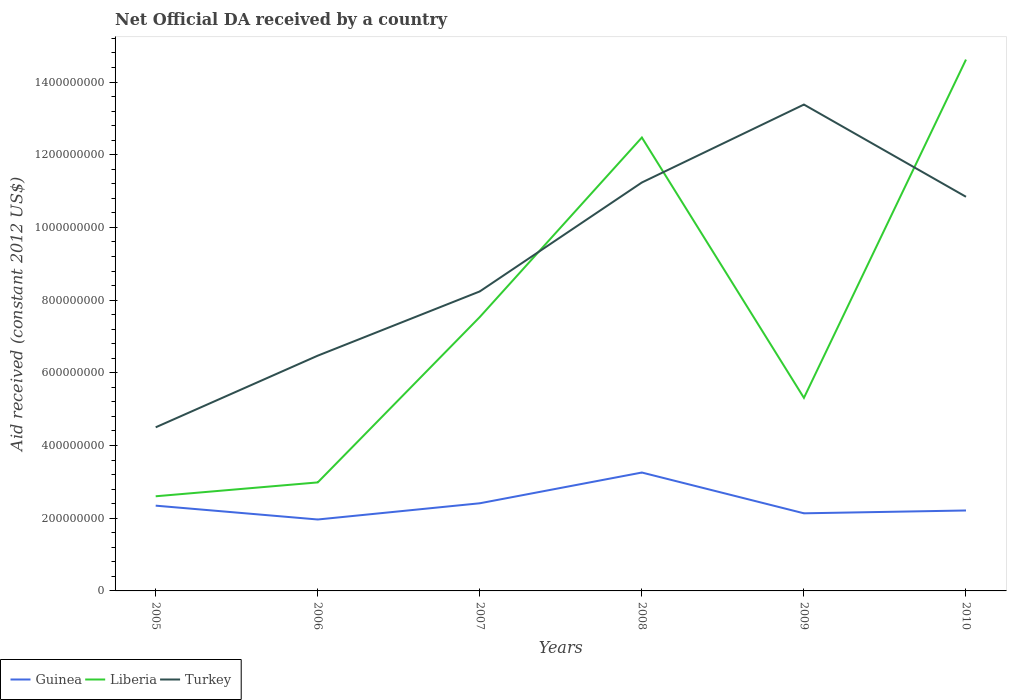How many different coloured lines are there?
Offer a terse response. 3. Does the line corresponding to Liberia intersect with the line corresponding to Turkey?
Give a very brief answer. Yes. Across all years, what is the maximum net official development assistance aid received in Liberia?
Keep it short and to the point. 2.60e+08. What is the total net official development assistance aid received in Liberia in the graph?
Your answer should be very brief. -1.16e+09. What is the difference between the highest and the second highest net official development assistance aid received in Liberia?
Offer a very short reply. 1.20e+09. What is the difference between the highest and the lowest net official development assistance aid received in Guinea?
Offer a terse response. 2. Is the net official development assistance aid received in Liberia strictly greater than the net official development assistance aid received in Turkey over the years?
Offer a terse response. No. How many years are there in the graph?
Keep it short and to the point. 6. What is the difference between two consecutive major ticks on the Y-axis?
Your answer should be compact. 2.00e+08. Where does the legend appear in the graph?
Provide a short and direct response. Bottom left. How are the legend labels stacked?
Your response must be concise. Horizontal. What is the title of the graph?
Give a very brief answer. Net Official DA received by a country. Does "Bahamas" appear as one of the legend labels in the graph?
Provide a succinct answer. No. What is the label or title of the Y-axis?
Keep it short and to the point. Aid received (constant 2012 US$). What is the Aid received (constant 2012 US$) in Guinea in 2005?
Offer a very short reply. 2.35e+08. What is the Aid received (constant 2012 US$) of Liberia in 2005?
Your answer should be compact. 2.60e+08. What is the Aid received (constant 2012 US$) in Turkey in 2005?
Offer a very short reply. 4.50e+08. What is the Aid received (constant 2012 US$) in Guinea in 2006?
Your response must be concise. 1.96e+08. What is the Aid received (constant 2012 US$) of Liberia in 2006?
Ensure brevity in your answer.  2.99e+08. What is the Aid received (constant 2012 US$) of Turkey in 2006?
Your answer should be compact. 6.47e+08. What is the Aid received (constant 2012 US$) in Guinea in 2007?
Give a very brief answer. 2.41e+08. What is the Aid received (constant 2012 US$) in Liberia in 2007?
Make the answer very short. 7.54e+08. What is the Aid received (constant 2012 US$) of Turkey in 2007?
Offer a very short reply. 8.24e+08. What is the Aid received (constant 2012 US$) in Guinea in 2008?
Your answer should be very brief. 3.26e+08. What is the Aid received (constant 2012 US$) in Liberia in 2008?
Offer a terse response. 1.25e+09. What is the Aid received (constant 2012 US$) in Turkey in 2008?
Provide a succinct answer. 1.12e+09. What is the Aid received (constant 2012 US$) of Guinea in 2009?
Your answer should be very brief. 2.14e+08. What is the Aid received (constant 2012 US$) in Liberia in 2009?
Ensure brevity in your answer.  5.31e+08. What is the Aid received (constant 2012 US$) in Turkey in 2009?
Your response must be concise. 1.34e+09. What is the Aid received (constant 2012 US$) of Guinea in 2010?
Provide a short and direct response. 2.21e+08. What is the Aid received (constant 2012 US$) of Liberia in 2010?
Provide a succinct answer. 1.46e+09. What is the Aid received (constant 2012 US$) in Turkey in 2010?
Give a very brief answer. 1.08e+09. Across all years, what is the maximum Aid received (constant 2012 US$) of Guinea?
Keep it short and to the point. 3.26e+08. Across all years, what is the maximum Aid received (constant 2012 US$) of Liberia?
Ensure brevity in your answer.  1.46e+09. Across all years, what is the maximum Aid received (constant 2012 US$) in Turkey?
Provide a succinct answer. 1.34e+09. Across all years, what is the minimum Aid received (constant 2012 US$) in Guinea?
Provide a short and direct response. 1.96e+08. Across all years, what is the minimum Aid received (constant 2012 US$) in Liberia?
Your answer should be very brief. 2.60e+08. Across all years, what is the minimum Aid received (constant 2012 US$) of Turkey?
Provide a short and direct response. 4.50e+08. What is the total Aid received (constant 2012 US$) in Guinea in the graph?
Provide a succinct answer. 1.43e+09. What is the total Aid received (constant 2012 US$) in Liberia in the graph?
Provide a short and direct response. 4.55e+09. What is the total Aid received (constant 2012 US$) of Turkey in the graph?
Provide a short and direct response. 5.47e+09. What is the difference between the Aid received (constant 2012 US$) in Guinea in 2005 and that in 2006?
Provide a short and direct response. 3.81e+07. What is the difference between the Aid received (constant 2012 US$) of Liberia in 2005 and that in 2006?
Ensure brevity in your answer.  -3.82e+07. What is the difference between the Aid received (constant 2012 US$) of Turkey in 2005 and that in 2006?
Your answer should be very brief. -1.97e+08. What is the difference between the Aid received (constant 2012 US$) of Guinea in 2005 and that in 2007?
Your answer should be compact. -6.56e+06. What is the difference between the Aid received (constant 2012 US$) of Liberia in 2005 and that in 2007?
Keep it short and to the point. -4.93e+08. What is the difference between the Aid received (constant 2012 US$) in Turkey in 2005 and that in 2007?
Give a very brief answer. -3.74e+08. What is the difference between the Aid received (constant 2012 US$) of Guinea in 2005 and that in 2008?
Provide a succinct answer. -9.11e+07. What is the difference between the Aid received (constant 2012 US$) of Liberia in 2005 and that in 2008?
Ensure brevity in your answer.  -9.87e+08. What is the difference between the Aid received (constant 2012 US$) in Turkey in 2005 and that in 2008?
Your answer should be very brief. -6.73e+08. What is the difference between the Aid received (constant 2012 US$) in Guinea in 2005 and that in 2009?
Give a very brief answer. 2.10e+07. What is the difference between the Aid received (constant 2012 US$) of Liberia in 2005 and that in 2009?
Your answer should be very brief. -2.71e+08. What is the difference between the Aid received (constant 2012 US$) in Turkey in 2005 and that in 2009?
Ensure brevity in your answer.  -8.88e+08. What is the difference between the Aid received (constant 2012 US$) in Guinea in 2005 and that in 2010?
Your answer should be very brief. 1.33e+07. What is the difference between the Aid received (constant 2012 US$) of Liberia in 2005 and that in 2010?
Your response must be concise. -1.20e+09. What is the difference between the Aid received (constant 2012 US$) in Turkey in 2005 and that in 2010?
Offer a very short reply. -6.34e+08. What is the difference between the Aid received (constant 2012 US$) in Guinea in 2006 and that in 2007?
Your answer should be compact. -4.46e+07. What is the difference between the Aid received (constant 2012 US$) of Liberia in 2006 and that in 2007?
Give a very brief answer. -4.55e+08. What is the difference between the Aid received (constant 2012 US$) of Turkey in 2006 and that in 2007?
Give a very brief answer. -1.77e+08. What is the difference between the Aid received (constant 2012 US$) in Guinea in 2006 and that in 2008?
Offer a terse response. -1.29e+08. What is the difference between the Aid received (constant 2012 US$) of Liberia in 2006 and that in 2008?
Your answer should be very brief. -9.49e+08. What is the difference between the Aid received (constant 2012 US$) in Turkey in 2006 and that in 2008?
Provide a succinct answer. -4.76e+08. What is the difference between the Aid received (constant 2012 US$) of Guinea in 2006 and that in 2009?
Make the answer very short. -1.70e+07. What is the difference between the Aid received (constant 2012 US$) of Liberia in 2006 and that in 2009?
Make the answer very short. -2.33e+08. What is the difference between the Aid received (constant 2012 US$) of Turkey in 2006 and that in 2009?
Offer a very short reply. -6.91e+08. What is the difference between the Aid received (constant 2012 US$) of Guinea in 2006 and that in 2010?
Your answer should be very brief. -2.48e+07. What is the difference between the Aid received (constant 2012 US$) of Liberia in 2006 and that in 2010?
Ensure brevity in your answer.  -1.16e+09. What is the difference between the Aid received (constant 2012 US$) in Turkey in 2006 and that in 2010?
Ensure brevity in your answer.  -4.37e+08. What is the difference between the Aid received (constant 2012 US$) of Guinea in 2007 and that in 2008?
Provide a short and direct response. -8.46e+07. What is the difference between the Aid received (constant 2012 US$) of Liberia in 2007 and that in 2008?
Offer a terse response. -4.94e+08. What is the difference between the Aid received (constant 2012 US$) of Turkey in 2007 and that in 2008?
Give a very brief answer. -3.00e+08. What is the difference between the Aid received (constant 2012 US$) in Guinea in 2007 and that in 2009?
Your answer should be very brief. 2.76e+07. What is the difference between the Aid received (constant 2012 US$) in Liberia in 2007 and that in 2009?
Provide a short and direct response. 2.22e+08. What is the difference between the Aid received (constant 2012 US$) in Turkey in 2007 and that in 2009?
Make the answer very short. -5.14e+08. What is the difference between the Aid received (constant 2012 US$) in Guinea in 2007 and that in 2010?
Keep it short and to the point. 1.98e+07. What is the difference between the Aid received (constant 2012 US$) of Liberia in 2007 and that in 2010?
Your response must be concise. -7.08e+08. What is the difference between the Aid received (constant 2012 US$) of Turkey in 2007 and that in 2010?
Make the answer very short. -2.60e+08. What is the difference between the Aid received (constant 2012 US$) in Guinea in 2008 and that in 2009?
Offer a terse response. 1.12e+08. What is the difference between the Aid received (constant 2012 US$) in Liberia in 2008 and that in 2009?
Keep it short and to the point. 7.16e+08. What is the difference between the Aid received (constant 2012 US$) in Turkey in 2008 and that in 2009?
Keep it short and to the point. -2.14e+08. What is the difference between the Aid received (constant 2012 US$) of Guinea in 2008 and that in 2010?
Your answer should be very brief. 1.04e+08. What is the difference between the Aid received (constant 2012 US$) of Liberia in 2008 and that in 2010?
Provide a succinct answer. -2.14e+08. What is the difference between the Aid received (constant 2012 US$) of Turkey in 2008 and that in 2010?
Your answer should be very brief. 3.93e+07. What is the difference between the Aid received (constant 2012 US$) in Guinea in 2009 and that in 2010?
Your response must be concise. -7.78e+06. What is the difference between the Aid received (constant 2012 US$) in Liberia in 2009 and that in 2010?
Give a very brief answer. -9.31e+08. What is the difference between the Aid received (constant 2012 US$) in Turkey in 2009 and that in 2010?
Provide a short and direct response. 2.54e+08. What is the difference between the Aid received (constant 2012 US$) of Guinea in 2005 and the Aid received (constant 2012 US$) of Liberia in 2006?
Offer a terse response. -6.40e+07. What is the difference between the Aid received (constant 2012 US$) of Guinea in 2005 and the Aid received (constant 2012 US$) of Turkey in 2006?
Keep it short and to the point. -4.13e+08. What is the difference between the Aid received (constant 2012 US$) of Liberia in 2005 and the Aid received (constant 2012 US$) of Turkey in 2006?
Your answer should be compact. -3.87e+08. What is the difference between the Aid received (constant 2012 US$) in Guinea in 2005 and the Aid received (constant 2012 US$) in Liberia in 2007?
Your answer should be very brief. -5.19e+08. What is the difference between the Aid received (constant 2012 US$) of Guinea in 2005 and the Aid received (constant 2012 US$) of Turkey in 2007?
Your answer should be very brief. -5.89e+08. What is the difference between the Aid received (constant 2012 US$) in Liberia in 2005 and the Aid received (constant 2012 US$) in Turkey in 2007?
Provide a short and direct response. -5.64e+08. What is the difference between the Aid received (constant 2012 US$) of Guinea in 2005 and the Aid received (constant 2012 US$) of Liberia in 2008?
Offer a very short reply. -1.01e+09. What is the difference between the Aid received (constant 2012 US$) in Guinea in 2005 and the Aid received (constant 2012 US$) in Turkey in 2008?
Provide a succinct answer. -8.89e+08. What is the difference between the Aid received (constant 2012 US$) of Liberia in 2005 and the Aid received (constant 2012 US$) of Turkey in 2008?
Keep it short and to the point. -8.63e+08. What is the difference between the Aid received (constant 2012 US$) in Guinea in 2005 and the Aid received (constant 2012 US$) in Liberia in 2009?
Offer a terse response. -2.97e+08. What is the difference between the Aid received (constant 2012 US$) in Guinea in 2005 and the Aid received (constant 2012 US$) in Turkey in 2009?
Keep it short and to the point. -1.10e+09. What is the difference between the Aid received (constant 2012 US$) in Liberia in 2005 and the Aid received (constant 2012 US$) in Turkey in 2009?
Provide a succinct answer. -1.08e+09. What is the difference between the Aid received (constant 2012 US$) of Guinea in 2005 and the Aid received (constant 2012 US$) of Liberia in 2010?
Provide a short and direct response. -1.23e+09. What is the difference between the Aid received (constant 2012 US$) of Guinea in 2005 and the Aid received (constant 2012 US$) of Turkey in 2010?
Ensure brevity in your answer.  -8.50e+08. What is the difference between the Aid received (constant 2012 US$) in Liberia in 2005 and the Aid received (constant 2012 US$) in Turkey in 2010?
Your answer should be very brief. -8.24e+08. What is the difference between the Aid received (constant 2012 US$) in Guinea in 2006 and the Aid received (constant 2012 US$) in Liberia in 2007?
Make the answer very short. -5.57e+08. What is the difference between the Aid received (constant 2012 US$) of Guinea in 2006 and the Aid received (constant 2012 US$) of Turkey in 2007?
Provide a short and direct response. -6.27e+08. What is the difference between the Aid received (constant 2012 US$) of Liberia in 2006 and the Aid received (constant 2012 US$) of Turkey in 2007?
Your answer should be very brief. -5.25e+08. What is the difference between the Aid received (constant 2012 US$) in Guinea in 2006 and the Aid received (constant 2012 US$) in Liberia in 2008?
Provide a short and direct response. -1.05e+09. What is the difference between the Aid received (constant 2012 US$) in Guinea in 2006 and the Aid received (constant 2012 US$) in Turkey in 2008?
Your response must be concise. -9.27e+08. What is the difference between the Aid received (constant 2012 US$) of Liberia in 2006 and the Aid received (constant 2012 US$) of Turkey in 2008?
Your answer should be compact. -8.25e+08. What is the difference between the Aid received (constant 2012 US$) in Guinea in 2006 and the Aid received (constant 2012 US$) in Liberia in 2009?
Ensure brevity in your answer.  -3.35e+08. What is the difference between the Aid received (constant 2012 US$) of Guinea in 2006 and the Aid received (constant 2012 US$) of Turkey in 2009?
Offer a very short reply. -1.14e+09. What is the difference between the Aid received (constant 2012 US$) of Liberia in 2006 and the Aid received (constant 2012 US$) of Turkey in 2009?
Provide a succinct answer. -1.04e+09. What is the difference between the Aid received (constant 2012 US$) of Guinea in 2006 and the Aid received (constant 2012 US$) of Liberia in 2010?
Give a very brief answer. -1.27e+09. What is the difference between the Aid received (constant 2012 US$) of Guinea in 2006 and the Aid received (constant 2012 US$) of Turkey in 2010?
Offer a very short reply. -8.88e+08. What is the difference between the Aid received (constant 2012 US$) of Liberia in 2006 and the Aid received (constant 2012 US$) of Turkey in 2010?
Make the answer very short. -7.86e+08. What is the difference between the Aid received (constant 2012 US$) in Guinea in 2007 and the Aid received (constant 2012 US$) in Liberia in 2008?
Provide a short and direct response. -1.01e+09. What is the difference between the Aid received (constant 2012 US$) in Guinea in 2007 and the Aid received (constant 2012 US$) in Turkey in 2008?
Provide a short and direct response. -8.82e+08. What is the difference between the Aid received (constant 2012 US$) of Liberia in 2007 and the Aid received (constant 2012 US$) of Turkey in 2008?
Offer a very short reply. -3.70e+08. What is the difference between the Aid received (constant 2012 US$) of Guinea in 2007 and the Aid received (constant 2012 US$) of Liberia in 2009?
Your response must be concise. -2.90e+08. What is the difference between the Aid received (constant 2012 US$) of Guinea in 2007 and the Aid received (constant 2012 US$) of Turkey in 2009?
Your answer should be compact. -1.10e+09. What is the difference between the Aid received (constant 2012 US$) of Liberia in 2007 and the Aid received (constant 2012 US$) of Turkey in 2009?
Make the answer very short. -5.84e+08. What is the difference between the Aid received (constant 2012 US$) in Guinea in 2007 and the Aid received (constant 2012 US$) in Liberia in 2010?
Offer a very short reply. -1.22e+09. What is the difference between the Aid received (constant 2012 US$) of Guinea in 2007 and the Aid received (constant 2012 US$) of Turkey in 2010?
Make the answer very short. -8.43e+08. What is the difference between the Aid received (constant 2012 US$) of Liberia in 2007 and the Aid received (constant 2012 US$) of Turkey in 2010?
Your response must be concise. -3.31e+08. What is the difference between the Aid received (constant 2012 US$) of Guinea in 2008 and the Aid received (constant 2012 US$) of Liberia in 2009?
Give a very brief answer. -2.05e+08. What is the difference between the Aid received (constant 2012 US$) of Guinea in 2008 and the Aid received (constant 2012 US$) of Turkey in 2009?
Keep it short and to the point. -1.01e+09. What is the difference between the Aid received (constant 2012 US$) in Liberia in 2008 and the Aid received (constant 2012 US$) in Turkey in 2009?
Your answer should be very brief. -9.07e+07. What is the difference between the Aid received (constant 2012 US$) of Guinea in 2008 and the Aid received (constant 2012 US$) of Liberia in 2010?
Make the answer very short. -1.14e+09. What is the difference between the Aid received (constant 2012 US$) in Guinea in 2008 and the Aid received (constant 2012 US$) in Turkey in 2010?
Make the answer very short. -7.59e+08. What is the difference between the Aid received (constant 2012 US$) of Liberia in 2008 and the Aid received (constant 2012 US$) of Turkey in 2010?
Give a very brief answer. 1.63e+08. What is the difference between the Aid received (constant 2012 US$) in Guinea in 2009 and the Aid received (constant 2012 US$) in Liberia in 2010?
Your answer should be compact. -1.25e+09. What is the difference between the Aid received (constant 2012 US$) in Guinea in 2009 and the Aid received (constant 2012 US$) in Turkey in 2010?
Provide a short and direct response. -8.71e+08. What is the difference between the Aid received (constant 2012 US$) of Liberia in 2009 and the Aid received (constant 2012 US$) of Turkey in 2010?
Provide a short and direct response. -5.53e+08. What is the average Aid received (constant 2012 US$) in Guinea per year?
Give a very brief answer. 2.39e+08. What is the average Aid received (constant 2012 US$) of Liberia per year?
Your answer should be compact. 7.59e+08. What is the average Aid received (constant 2012 US$) of Turkey per year?
Offer a terse response. 9.11e+08. In the year 2005, what is the difference between the Aid received (constant 2012 US$) in Guinea and Aid received (constant 2012 US$) in Liberia?
Give a very brief answer. -2.58e+07. In the year 2005, what is the difference between the Aid received (constant 2012 US$) of Guinea and Aid received (constant 2012 US$) of Turkey?
Make the answer very short. -2.16e+08. In the year 2005, what is the difference between the Aid received (constant 2012 US$) of Liberia and Aid received (constant 2012 US$) of Turkey?
Ensure brevity in your answer.  -1.90e+08. In the year 2006, what is the difference between the Aid received (constant 2012 US$) in Guinea and Aid received (constant 2012 US$) in Liberia?
Provide a short and direct response. -1.02e+08. In the year 2006, what is the difference between the Aid received (constant 2012 US$) of Guinea and Aid received (constant 2012 US$) of Turkey?
Make the answer very short. -4.51e+08. In the year 2006, what is the difference between the Aid received (constant 2012 US$) of Liberia and Aid received (constant 2012 US$) of Turkey?
Your answer should be very brief. -3.49e+08. In the year 2007, what is the difference between the Aid received (constant 2012 US$) in Guinea and Aid received (constant 2012 US$) in Liberia?
Provide a short and direct response. -5.12e+08. In the year 2007, what is the difference between the Aid received (constant 2012 US$) of Guinea and Aid received (constant 2012 US$) of Turkey?
Ensure brevity in your answer.  -5.83e+08. In the year 2007, what is the difference between the Aid received (constant 2012 US$) in Liberia and Aid received (constant 2012 US$) in Turkey?
Make the answer very short. -7.04e+07. In the year 2008, what is the difference between the Aid received (constant 2012 US$) of Guinea and Aid received (constant 2012 US$) of Liberia?
Offer a terse response. -9.22e+08. In the year 2008, what is the difference between the Aid received (constant 2012 US$) in Guinea and Aid received (constant 2012 US$) in Turkey?
Make the answer very short. -7.98e+08. In the year 2008, what is the difference between the Aid received (constant 2012 US$) in Liberia and Aid received (constant 2012 US$) in Turkey?
Offer a terse response. 1.24e+08. In the year 2009, what is the difference between the Aid received (constant 2012 US$) in Guinea and Aid received (constant 2012 US$) in Liberia?
Provide a succinct answer. -3.18e+08. In the year 2009, what is the difference between the Aid received (constant 2012 US$) of Guinea and Aid received (constant 2012 US$) of Turkey?
Your response must be concise. -1.12e+09. In the year 2009, what is the difference between the Aid received (constant 2012 US$) of Liberia and Aid received (constant 2012 US$) of Turkey?
Offer a very short reply. -8.07e+08. In the year 2010, what is the difference between the Aid received (constant 2012 US$) in Guinea and Aid received (constant 2012 US$) in Liberia?
Make the answer very short. -1.24e+09. In the year 2010, what is the difference between the Aid received (constant 2012 US$) of Guinea and Aid received (constant 2012 US$) of Turkey?
Ensure brevity in your answer.  -8.63e+08. In the year 2010, what is the difference between the Aid received (constant 2012 US$) of Liberia and Aid received (constant 2012 US$) of Turkey?
Ensure brevity in your answer.  3.77e+08. What is the ratio of the Aid received (constant 2012 US$) of Guinea in 2005 to that in 2006?
Ensure brevity in your answer.  1.19. What is the ratio of the Aid received (constant 2012 US$) of Liberia in 2005 to that in 2006?
Ensure brevity in your answer.  0.87. What is the ratio of the Aid received (constant 2012 US$) of Turkey in 2005 to that in 2006?
Provide a succinct answer. 0.7. What is the ratio of the Aid received (constant 2012 US$) in Guinea in 2005 to that in 2007?
Offer a terse response. 0.97. What is the ratio of the Aid received (constant 2012 US$) of Liberia in 2005 to that in 2007?
Provide a short and direct response. 0.35. What is the ratio of the Aid received (constant 2012 US$) in Turkey in 2005 to that in 2007?
Give a very brief answer. 0.55. What is the ratio of the Aid received (constant 2012 US$) in Guinea in 2005 to that in 2008?
Ensure brevity in your answer.  0.72. What is the ratio of the Aid received (constant 2012 US$) of Liberia in 2005 to that in 2008?
Your answer should be compact. 0.21. What is the ratio of the Aid received (constant 2012 US$) in Turkey in 2005 to that in 2008?
Your response must be concise. 0.4. What is the ratio of the Aid received (constant 2012 US$) of Guinea in 2005 to that in 2009?
Keep it short and to the point. 1.1. What is the ratio of the Aid received (constant 2012 US$) in Liberia in 2005 to that in 2009?
Offer a very short reply. 0.49. What is the ratio of the Aid received (constant 2012 US$) in Turkey in 2005 to that in 2009?
Your answer should be very brief. 0.34. What is the ratio of the Aid received (constant 2012 US$) of Guinea in 2005 to that in 2010?
Give a very brief answer. 1.06. What is the ratio of the Aid received (constant 2012 US$) in Liberia in 2005 to that in 2010?
Offer a very short reply. 0.18. What is the ratio of the Aid received (constant 2012 US$) of Turkey in 2005 to that in 2010?
Make the answer very short. 0.42. What is the ratio of the Aid received (constant 2012 US$) in Guinea in 2006 to that in 2007?
Offer a very short reply. 0.81. What is the ratio of the Aid received (constant 2012 US$) in Liberia in 2006 to that in 2007?
Give a very brief answer. 0.4. What is the ratio of the Aid received (constant 2012 US$) in Turkey in 2006 to that in 2007?
Your response must be concise. 0.79. What is the ratio of the Aid received (constant 2012 US$) in Guinea in 2006 to that in 2008?
Offer a terse response. 0.6. What is the ratio of the Aid received (constant 2012 US$) of Liberia in 2006 to that in 2008?
Give a very brief answer. 0.24. What is the ratio of the Aid received (constant 2012 US$) of Turkey in 2006 to that in 2008?
Give a very brief answer. 0.58. What is the ratio of the Aid received (constant 2012 US$) in Guinea in 2006 to that in 2009?
Provide a succinct answer. 0.92. What is the ratio of the Aid received (constant 2012 US$) of Liberia in 2006 to that in 2009?
Provide a succinct answer. 0.56. What is the ratio of the Aid received (constant 2012 US$) of Turkey in 2006 to that in 2009?
Keep it short and to the point. 0.48. What is the ratio of the Aid received (constant 2012 US$) of Guinea in 2006 to that in 2010?
Give a very brief answer. 0.89. What is the ratio of the Aid received (constant 2012 US$) in Liberia in 2006 to that in 2010?
Give a very brief answer. 0.2. What is the ratio of the Aid received (constant 2012 US$) of Turkey in 2006 to that in 2010?
Offer a very short reply. 0.6. What is the ratio of the Aid received (constant 2012 US$) of Guinea in 2007 to that in 2008?
Ensure brevity in your answer.  0.74. What is the ratio of the Aid received (constant 2012 US$) in Liberia in 2007 to that in 2008?
Offer a terse response. 0.6. What is the ratio of the Aid received (constant 2012 US$) of Turkey in 2007 to that in 2008?
Your response must be concise. 0.73. What is the ratio of the Aid received (constant 2012 US$) of Guinea in 2007 to that in 2009?
Offer a terse response. 1.13. What is the ratio of the Aid received (constant 2012 US$) of Liberia in 2007 to that in 2009?
Provide a short and direct response. 1.42. What is the ratio of the Aid received (constant 2012 US$) of Turkey in 2007 to that in 2009?
Make the answer very short. 0.62. What is the ratio of the Aid received (constant 2012 US$) in Guinea in 2007 to that in 2010?
Your answer should be compact. 1.09. What is the ratio of the Aid received (constant 2012 US$) of Liberia in 2007 to that in 2010?
Offer a terse response. 0.52. What is the ratio of the Aid received (constant 2012 US$) in Turkey in 2007 to that in 2010?
Give a very brief answer. 0.76. What is the ratio of the Aid received (constant 2012 US$) of Guinea in 2008 to that in 2009?
Offer a terse response. 1.53. What is the ratio of the Aid received (constant 2012 US$) of Liberia in 2008 to that in 2009?
Ensure brevity in your answer.  2.35. What is the ratio of the Aid received (constant 2012 US$) of Turkey in 2008 to that in 2009?
Provide a short and direct response. 0.84. What is the ratio of the Aid received (constant 2012 US$) in Guinea in 2008 to that in 2010?
Offer a terse response. 1.47. What is the ratio of the Aid received (constant 2012 US$) of Liberia in 2008 to that in 2010?
Offer a terse response. 0.85. What is the ratio of the Aid received (constant 2012 US$) of Turkey in 2008 to that in 2010?
Keep it short and to the point. 1.04. What is the ratio of the Aid received (constant 2012 US$) of Guinea in 2009 to that in 2010?
Provide a short and direct response. 0.96. What is the ratio of the Aid received (constant 2012 US$) of Liberia in 2009 to that in 2010?
Keep it short and to the point. 0.36. What is the ratio of the Aid received (constant 2012 US$) in Turkey in 2009 to that in 2010?
Make the answer very short. 1.23. What is the difference between the highest and the second highest Aid received (constant 2012 US$) in Guinea?
Keep it short and to the point. 8.46e+07. What is the difference between the highest and the second highest Aid received (constant 2012 US$) of Liberia?
Your response must be concise. 2.14e+08. What is the difference between the highest and the second highest Aid received (constant 2012 US$) in Turkey?
Your answer should be very brief. 2.14e+08. What is the difference between the highest and the lowest Aid received (constant 2012 US$) in Guinea?
Ensure brevity in your answer.  1.29e+08. What is the difference between the highest and the lowest Aid received (constant 2012 US$) of Liberia?
Provide a short and direct response. 1.20e+09. What is the difference between the highest and the lowest Aid received (constant 2012 US$) in Turkey?
Give a very brief answer. 8.88e+08. 